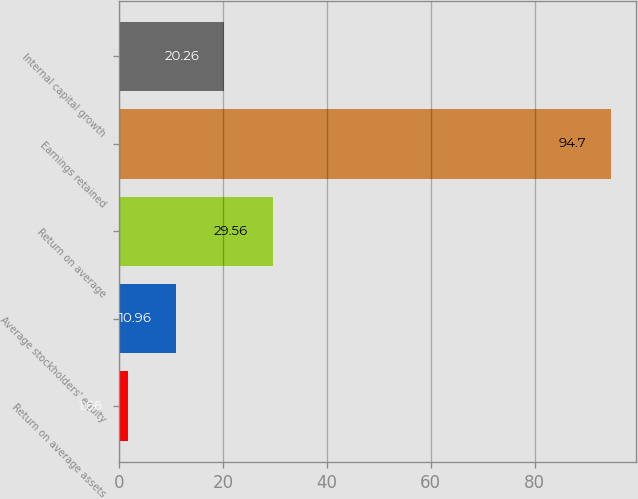Convert chart to OTSL. <chart><loc_0><loc_0><loc_500><loc_500><bar_chart><fcel>Return on average assets<fcel>Average stockholders' equity<fcel>Return on average<fcel>Earnings retained<fcel>Internal capital growth<nl><fcel>1.66<fcel>10.96<fcel>29.56<fcel>94.7<fcel>20.26<nl></chart> 